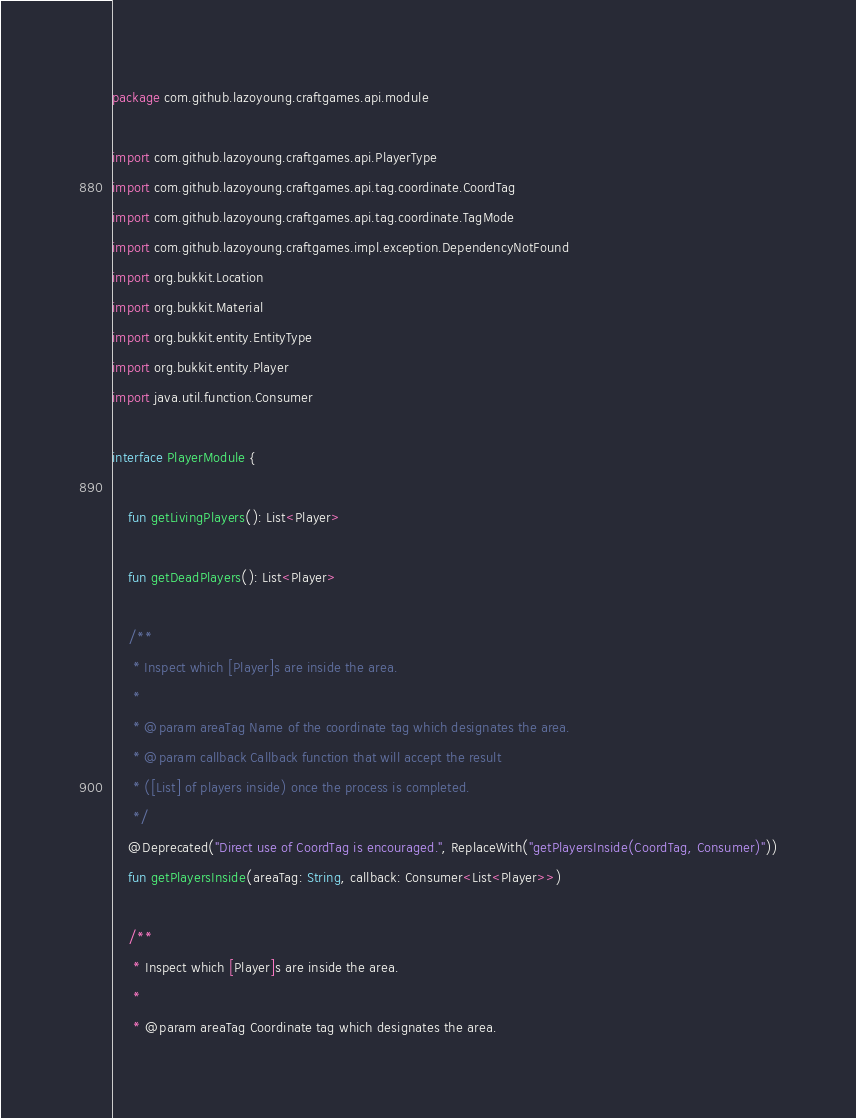Convert code to text. <code><loc_0><loc_0><loc_500><loc_500><_Kotlin_>package com.github.lazoyoung.craftgames.api.module

import com.github.lazoyoung.craftgames.api.PlayerType
import com.github.lazoyoung.craftgames.api.tag.coordinate.CoordTag
import com.github.lazoyoung.craftgames.api.tag.coordinate.TagMode
import com.github.lazoyoung.craftgames.impl.exception.DependencyNotFound
import org.bukkit.Location
import org.bukkit.Material
import org.bukkit.entity.EntityType
import org.bukkit.entity.Player
import java.util.function.Consumer

interface PlayerModule {

    fun getLivingPlayers(): List<Player>

    fun getDeadPlayers(): List<Player>

    /**
     * Inspect which [Player]s are inside the area.
     *
     * @param areaTag Name of the coordinate tag which designates the area.
     * @param callback Callback function that will accept the result
     * ([List] of players inside) once the process is completed.
     */
    @Deprecated("Direct use of CoordTag is encouraged.", ReplaceWith("getPlayersInside(CoordTag, Consumer)"))
    fun getPlayersInside(areaTag: String, callback: Consumer<List<Player>>)

    /**
     * Inspect which [Player]s are inside the area.
     *
     * @param areaTag Coordinate tag which designates the area.</code> 